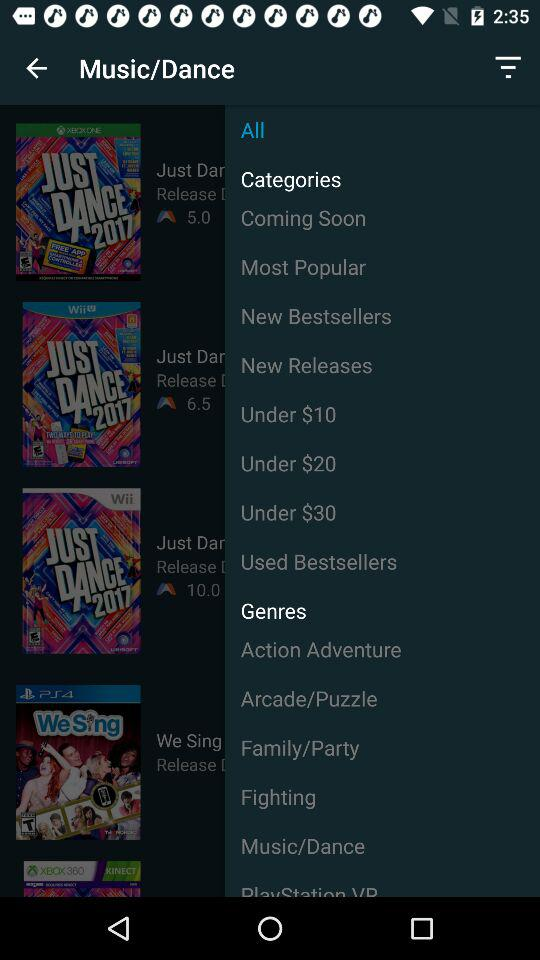Which are the different new releases?
When the provided information is insufficient, respond with <no answer>. <no answer> 